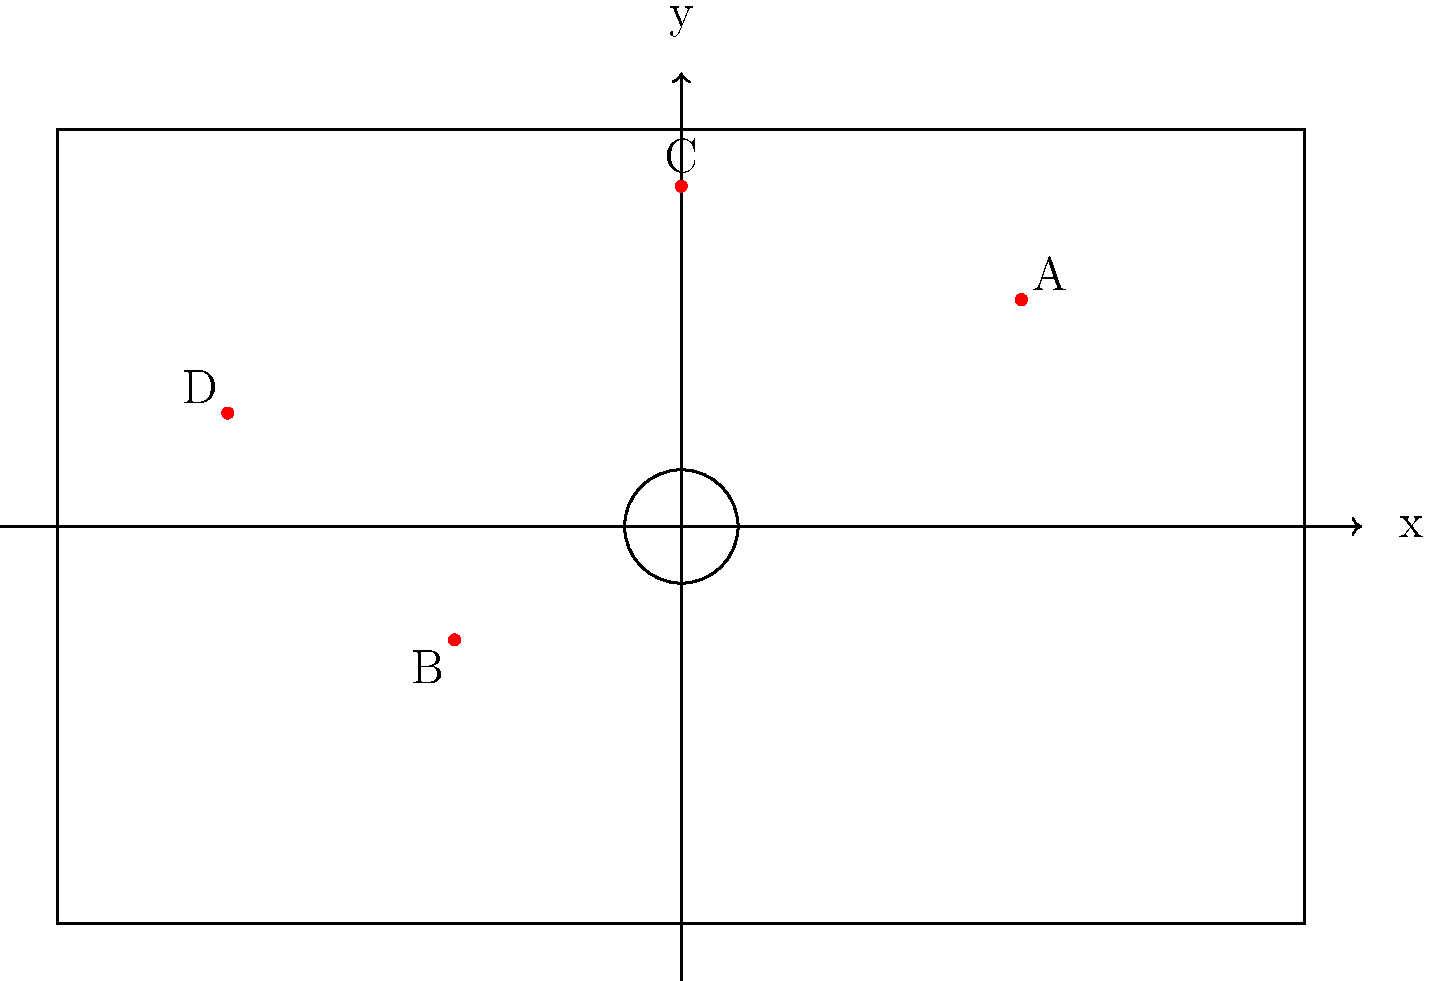In the diagram above, four FC Nürnberg players (A, B, C, and D) are positioned on a football pitch represented by a coordinate system. The x-axis runs along the length of the pitch, and the y-axis along the width. Each unit represents 1 meter. Which player is positioned closest to the center of the pitch at coordinates (0,0)? To determine which player is closest to the center of the pitch (0,0), we need to calculate the distance of each player from the origin using the distance formula:

Distance = $\sqrt{(x_2 - x_1)^2 + (y_2 - y_1)^2}$

Where $(x_1, y_1)$ is (0,0) and $(x_2, y_2)$ is the player's position.

Let's calculate for each player:

1. Player A (3,2):
   Distance = $\sqrt{(3-0)^2 + (2-0)^2} = \sqrt{9 + 4} = \sqrt{13} \approx 3.61$ meters

2. Player B (-2,-1):
   Distance = $\sqrt{(-2-0)^2 + (-1-0)^2} = \sqrt{4 + 1} = \sqrt{5} \approx 2.24$ meters

3. Player C (0,3):
   Distance = $\sqrt{(0-0)^2 + (3-0)^2} = \sqrt{0 + 9} = 3$ meters

4. Player D (-4,1):
   Distance = $\sqrt{(-4-0)^2 + (1-0)^2} = \sqrt{16 + 1} = \sqrt{17} \approx 4.12$ meters

The player with the shortest distance to the center is closest to (0,0).
Answer: Player B 